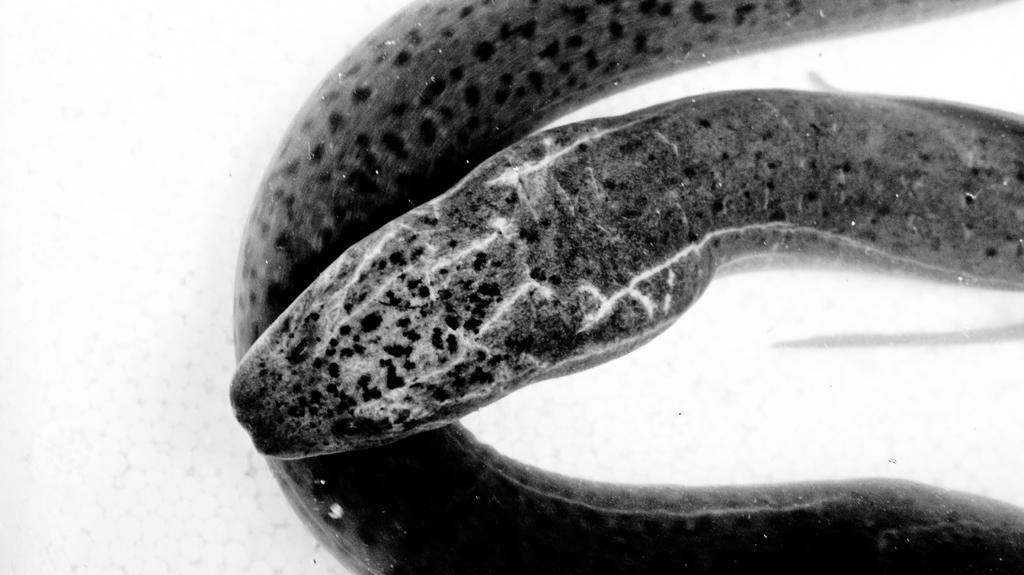What type of animal is in the image? There is a snake in the image. What color scheme is used in the image? The image is black and white. What type of yard can be seen in the image? There is no yard present in the image; it features a snake. How does the town look in the image? There is no town present in the image; it features a snake in black and white. 